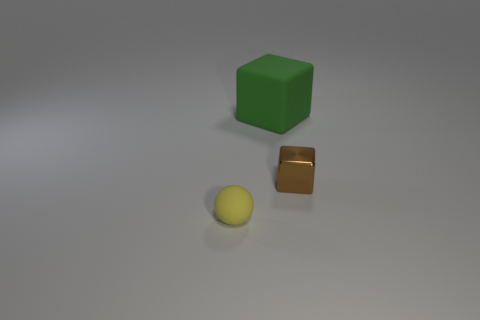Add 1 tiny yellow matte things. How many objects exist? 4 Subtract all balls. How many objects are left? 2 Add 2 yellow rubber cylinders. How many yellow rubber cylinders exist? 2 Subtract 0 gray blocks. How many objects are left? 3 Subtract all tiny metallic blocks. Subtract all big blue spheres. How many objects are left? 2 Add 3 green matte things. How many green matte things are left? 4 